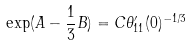Convert formula to latex. <formula><loc_0><loc_0><loc_500><loc_500>\exp ( A - \frac { 1 } { 3 } B ) = C \theta _ { 1 1 } ^ { \prime } ( 0 ) ^ { - 1 / 3 }</formula> 